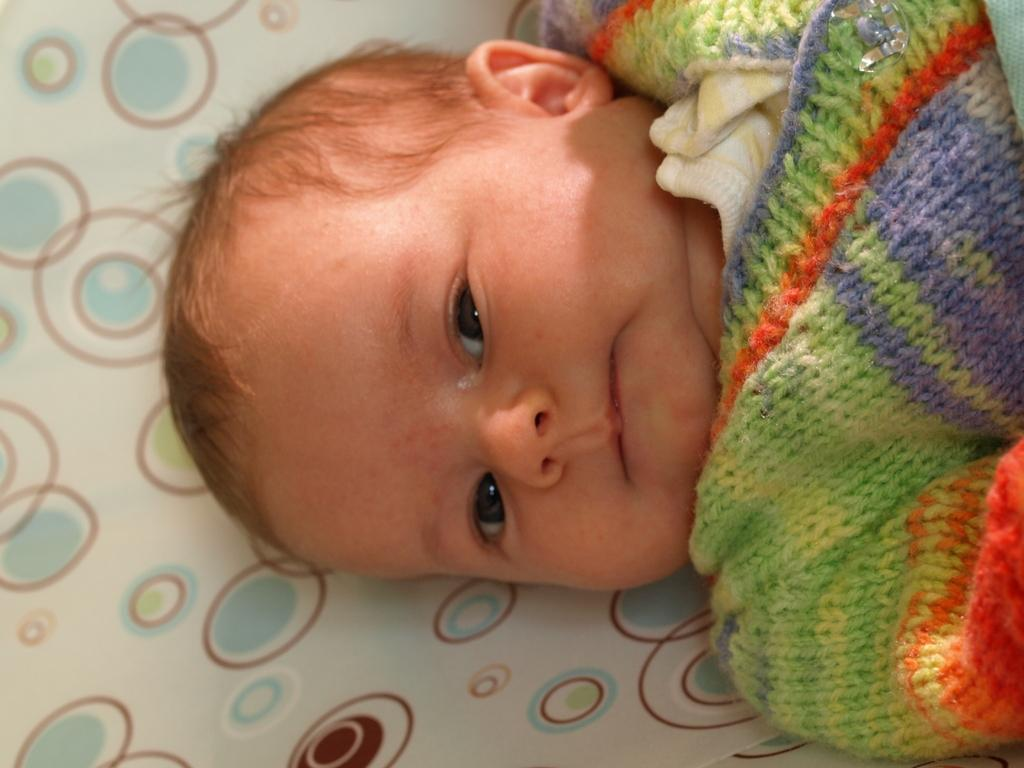What is the main subject of the image? The main subject of the image is a baby. What is the baby doing in the image? The baby is sleeping in the image. Where is the baby located in the image? The baby is on a bed in the image. What type of river can be seen in the background of the image? There is no river present in the image; it features a baby sleeping on a bed. 